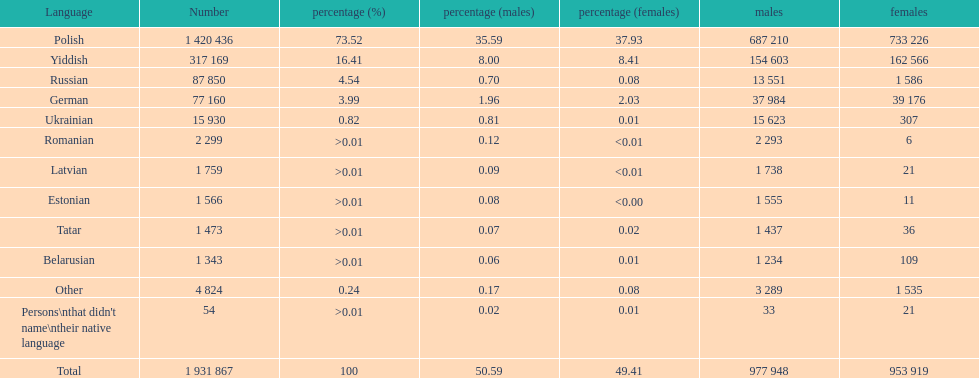What is the highest percentage of speakers other than polish? Yiddish. 